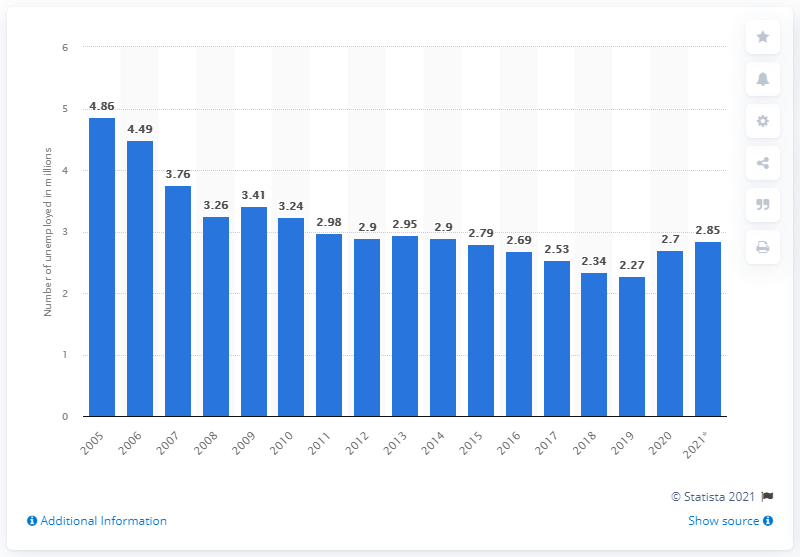List a handful of essential elements in this visual. In 2021, there were 2.85 unemployed individuals in Germany. 